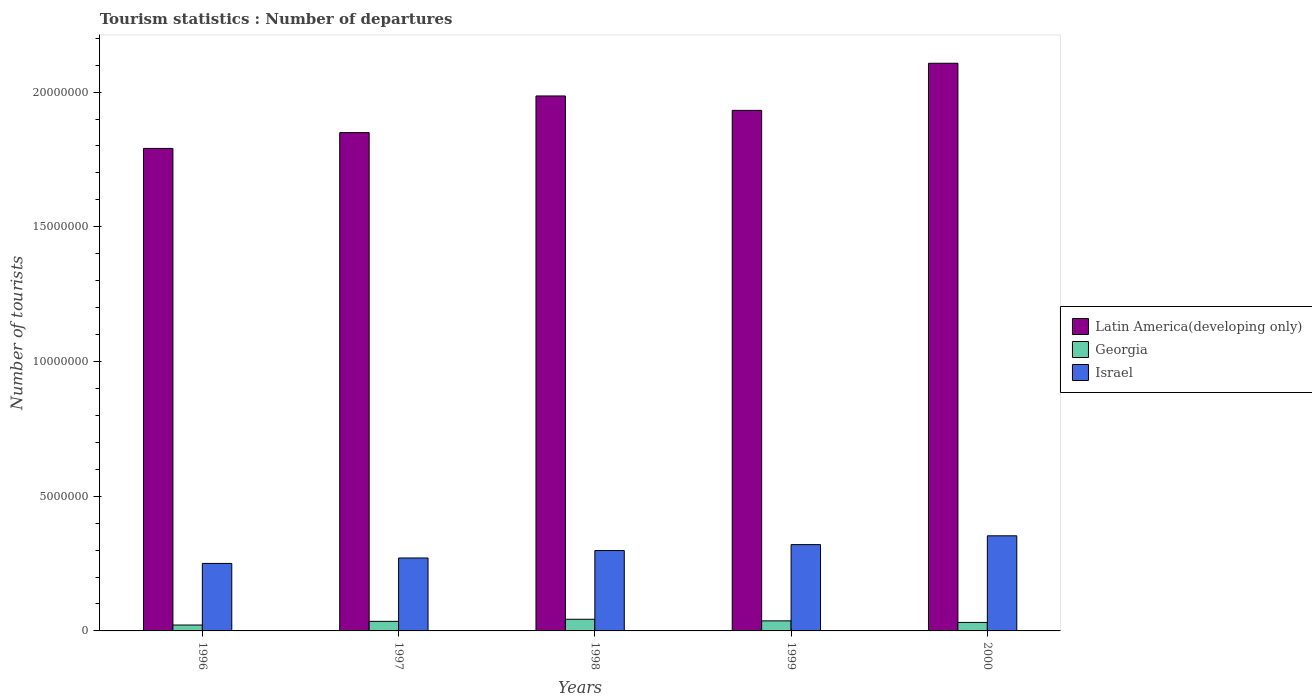How many groups of bars are there?
Keep it short and to the point. 5. Are the number of bars per tick equal to the number of legend labels?
Your response must be concise. Yes. How many bars are there on the 1st tick from the left?
Make the answer very short. 3. How many bars are there on the 4th tick from the right?
Keep it short and to the point. 3. What is the label of the 1st group of bars from the left?
Make the answer very short. 1996. What is the number of tourist departures in Latin America(developing only) in 1999?
Make the answer very short. 1.93e+07. Across all years, what is the maximum number of tourist departures in Georgia?
Your response must be concise. 4.33e+05. Across all years, what is the minimum number of tourist departures in Israel?
Your response must be concise. 2.50e+06. In which year was the number of tourist departures in Latin America(developing only) maximum?
Your response must be concise. 2000. In which year was the number of tourist departures in Georgia minimum?
Your response must be concise. 1996. What is the total number of tourist departures in Israel in the graph?
Your answer should be compact. 1.49e+07. What is the difference between the number of tourist departures in Israel in 1996 and that in 2000?
Offer a terse response. -1.02e+06. What is the difference between the number of tourist departures in Latin America(developing only) in 1998 and the number of tourist departures in Israel in 1999?
Make the answer very short. 1.67e+07. What is the average number of tourist departures in Georgia per year?
Ensure brevity in your answer.  3.39e+05. In the year 1996, what is the difference between the number of tourist departures in Israel and number of tourist departures in Latin America(developing only)?
Ensure brevity in your answer.  -1.54e+07. In how many years, is the number of tourist departures in Latin America(developing only) greater than 11000000?
Make the answer very short. 5. What is the ratio of the number of tourist departures in Israel in 1997 to that in 1998?
Provide a succinct answer. 0.91. What is the difference between the highest and the lowest number of tourist departures in Georgia?
Your response must be concise. 2.14e+05. In how many years, is the number of tourist departures in Georgia greater than the average number of tourist departures in Georgia taken over all years?
Your response must be concise. 3. Is the sum of the number of tourist departures in Israel in 1996 and 2000 greater than the maximum number of tourist departures in Latin America(developing only) across all years?
Make the answer very short. No. What does the 3rd bar from the left in 1996 represents?
Provide a short and direct response. Israel. What does the 1st bar from the right in 1996 represents?
Offer a terse response. Israel. Is it the case that in every year, the sum of the number of tourist departures in Latin America(developing only) and number of tourist departures in Israel is greater than the number of tourist departures in Georgia?
Keep it short and to the point. Yes. How many years are there in the graph?
Offer a terse response. 5. What is the difference between two consecutive major ticks on the Y-axis?
Provide a succinct answer. 5.00e+06. How many legend labels are there?
Keep it short and to the point. 3. How are the legend labels stacked?
Keep it short and to the point. Vertical. What is the title of the graph?
Your answer should be compact. Tourism statistics : Number of departures. Does "Djibouti" appear as one of the legend labels in the graph?
Offer a terse response. No. What is the label or title of the X-axis?
Make the answer very short. Years. What is the label or title of the Y-axis?
Your response must be concise. Number of tourists. What is the Number of tourists of Latin America(developing only) in 1996?
Your response must be concise. 1.79e+07. What is the Number of tourists in Georgia in 1996?
Your response must be concise. 2.19e+05. What is the Number of tourists of Israel in 1996?
Your answer should be compact. 2.50e+06. What is the Number of tourists of Latin America(developing only) in 1997?
Ensure brevity in your answer.  1.85e+07. What is the Number of tourists of Georgia in 1997?
Give a very brief answer. 3.55e+05. What is the Number of tourists of Israel in 1997?
Provide a succinct answer. 2.71e+06. What is the Number of tourists in Latin America(developing only) in 1998?
Keep it short and to the point. 1.99e+07. What is the Number of tourists of Georgia in 1998?
Your answer should be compact. 4.33e+05. What is the Number of tourists in Israel in 1998?
Ensure brevity in your answer.  2.98e+06. What is the Number of tourists of Latin America(developing only) in 1999?
Your answer should be compact. 1.93e+07. What is the Number of tourists of Georgia in 1999?
Your answer should be very brief. 3.73e+05. What is the Number of tourists in Israel in 1999?
Your answer should be compact. 3.20e+06. What is the Number of tourists of Latin America(developing only) in 2000?
Offer a terse response. 2.11e+07. What is the Number of tourists of Georgia in 2000?
Your response must be concise. 3.15e+05. What is the Number of tourists in Israel in 2000?
Your response must be concise. 3.53e+06. Across all years, what is the maximum Number of tourists in Latin America(developing only)?
Offer a terse response. 2.11e+07. Across all years, what is the maximum Number of tourists of Georgia?
Your answer should be very brief. 4.33e+05. Across all years, what is the maximum Number of tourists in Israel?
Provide a succinct answer. 3.53e+06. Across all years, what is the minimum Number of tourists in Latin America(developing only)?
Your response must be concise. 1.79e+07. Across all years, what is the minimum Number of tourists of Georgia?
Your response must be concise. 2.19e+05. Across all years, what is the minimum Number of tourists in Israel?
Offer a very short reply. 2.50e+06. What is the total Number of tourists in Latin America(developing only) in the graph?
Keep it short and to the point. 9.66e+07. What is the total Number of tourists in Georgia in the graph?
Make the answer very short. 1.70e+06. What is the total Number of tourists of Israel in the graph?
Make the answer very short. 1.49e+07. What is the difference between the Number of tourists of Latin America(developing only) in 1996 and that in 1997?
Your answer should be compact. -5.87e+05. What is the difference between the Number of tourists in Georgia in 1996 and that in 1997?
Your response must be concise. -1.36e+05. What is the difference between the Number of tourists in Israel in 1996 and that in 1997?
Keep it short and to the point. -2.02e+05. What is the difference between the Number of tourists in Latin America(developing only) in 1996 and that in 1998?
Your answer should be very brief. -1.95e+06. What is the difference between the Number of tourists of Georgia in 1996 and that in 1998?
Keep it short and to the point. -2.14e+05. What is the difference between the Number of tourists in Israel in 1996 and that in 1998?
Your answer should be very brief. -4.78e+05. What is the difference between the Number of tourists in Latin America(developing only) in 1996 and that in 1999?
Provide a short and direct response. -1.41e+06. What is the difference between the Number of tourists of Georgia in 1996 and that in 1999?
Give a very brief answer. -1.54e+05. What is the difference between the Number of tourists of Israel in 1996 and that in 1999?
Provide a short and direct response. -6.98e+05. What is the difference between the Number of tourists in Latin America(developing only) in 1996 and that in 2000?
Your response must be concise. -3.16e+06. What is the difference between the Number of tourists of Georgia in 1996 and that in 2000?
Offer a very short reply. -9.60e+04. What is the difference between the Number of tourists in Israel in 1996 and that in 2000?
Your answer should be very brief. -1.02e+06. What is the difference between the Number of tourists in Latin America(developing only) in 1997 and that in 1998?
Ensure brevity in your answer.  -1.36e+06. What is the difference between the Number of tourists of Georgia in 1997 and that in 1998?
Give a very brief answer. -7.80e+04. What is the difference between the Number of tourists in Israel in 1997 and that in 1998?
Provide a short and direct response. -2.76e+05. What is the difference between the Number of tourists in Latin America(developing only) in 1997 and that in 1999?
Your answer should be compact. -8.26e+05. What is the difference between the Number of tourists in Georgia in 1997 and that in 1999?
Ensure brevity in your answer.  -1.80e+04. What is the difference between the Number of tourists of Israel in 1997 and that in 1999?
Offer a very short reply. -4.96e+05. What is the difference between the Number of tourists of Latin America(developing only) in 1997 and that in 2000?
Offer a terse response. -2.57e+06. What is the difference between the Number of tourists of Israel in 1997 and that in 2000?
Your answer should be very brief. -8.23e+05. What is the difference between the Number of tourists of Latin America(developing only) in 1998 and that in 1999?
Your answer should be very brief. 5.35e+05. What is the difference between the Number of tourists of Latin America(developing only) in 1998 and that in 2000?
Your answer should be compact. -1.21e+06. What is the difference between the Number of tourists of Georgia in 1998 and that in 2000?
Provide a short and direct response. 1.18e+05. What is the difference between the Number of tourists of Israel in 1998 and that in 2000?
Offer a very short reply. -5.47e+05. What is the difference between the Number of tourists in Latin America(developing only) in 1999 and that in 2000?
Your answer should be compact. -1.75e+06. What is the difference between the Number of tourists of Georgia in 1999 and that in 2000?
Provide a short and direct response. 5.80e+04. What is the difference between the Number of tourists in Israel in 1999 and that in 2000?
Provide a short and direct response. -3.27e+05. What is the difference between the Number of tourists of Latin America(developing only) in 1996 and the Number of tourists of Georgia in 1997?
Give a very brief answer. 1.76e+07. What is the difference between the Number of tourists in Latin America(developing only) in 1996 and the Number of tourists in Israel in 1997?
Offer a very short reply. 1.52e+07. What is the difference between the Number of tourists in Georgia in 1996 and the Number of tourists in Israel in 1997?
Offer a terse response. -2.49e+06. What is the difference between the Number of tourists of Latin America(developing only) in 1996 and the Number of tourists of Georgia in 1998?
Make the answer very short. 1.75e+07. What is the difference between the Number of tourists of Latin America(developing only) in 1996 and the Number of tourists of Israel in 1998?
Provide a succinct answer. 1.49e+07. What is the difference between the Number of tourists of Georgia in 1996 and the Number of tourists of Israel in 1998?
Your answer should be compact. -2.76e+06. What is the difference between the Number of tourists in Latin America(developing only) in 1996 and the Number of tourists in Georgia in 1999?
Make the answer very short. 1.75e+07. What is the difference between the Number of tourists in Latin America(developing only) in 1996 and the Number of tourists in Israel in 1999?
Your response must be concise. 1.47e+07. What is the difference between the Number of tourists in Georgia in 1996 and the Number of tourists in Israel in 1999?
Your answer should be very brief. -2.98e+06. What is the difference between the Number of tourists in Latin America(developing only) in 1996 and the Number of tourists in Georgia in 2000?
Your answer should be very brief. 1.76e+07. What is the difference between the Number of tourists in Latin America(developing only) in 1996 and the Number of tourists in Israel in 2000?
Provide a short and direct response. 1.44e+07. What is the difference between the Number of tourists of Georgia in 1996 and the Number of tourists of Israel in 2000?
Your response must be concise. -3.31e+06. What is the difference between the Number of tourists in Latin America(developing only) in 1997 and the Number of tourists in Georgia in 1998?
Give a very brief answer. 1.81e+07. What is the difference between the Number of tourists in Latin America(developing only) in 1997 and the Number of tourists in Israel in 1998?
Give a very brief answer. 1.55e+07. What is the difference between the Number of tourists in Georgia in 1997 and the Number of tourists in Israel in 1998?
Provide a short and direct response. -2.63e+06. What is the difference between the Number of tourists of Latin America(developing only) in 1997 and the Number of tourists of Georgia in 1999?
Provide a succinct answer. 1.81e+07. What is the difference between the Number of tourists in Latin America(developing only) in 1997 and the Number of tourists in Israel in 1999?
Provide a succinct answer. 1.53e+07. What is the difference between the Number of tourists in Georgia in 1997 and the Number of tourists in Israel in 1999?
Your response must be concise. -2.85e+06. What is the difference between the Number of tourists of Latin America(developing only) in 1997 and the Number of tourists of Georgia in 2000?
Offer a very short reply. 1.82e+07. What is the difference between the Number of tourists of Latin America(developing only) in 1997 and the Number of tourists of Israel in 2000?
Ensure brevity in your answer.  1.50e+07. What is the difference between the Number of tourists of Georgia in 1997 and the Number of tourists of Israel in 2000?
Provide a short and direct response. -3.18e+06. What is the difference between the Number of tourists of Latin America(developing only) in 1998 and the Number of tourists of Georgia in 1999?
Make the answer very short. 1.95e+07. What is the difference between the Number of tourists in Latin America(developing only) in 1998 and the Number of tourists in Israel in 1999?
Give a very brief answer. 1.67e+07. What is the difference between the Number of tourists in Georgia in 1998 and the Number of tourists in Israel in 1999?
Your response must be concise. -2.77e+06. What is the difference between the Number of tourists in Latin America(developing only) in 1998 and the Number of tourists in Georgia in 2000?
Provide a short and direct response. 1.95e+07. What is the difference between the Number of tourists in Latin America(developing only) in 1998 and the Number of tourists in Israel in 2000?
Keep it short and to the point. 1.63e+07. What is the difference between the Number of tourists in Georgia in 1998 and the Number of tourists in Israel in 2000?
Provide a succinct answer. -3.10e+06. What is the difference between the Number of tourists in Latin America(developing only) in 1999 and the Number of tourists in Georgia in 2000?
Your answer should be very brief. 1.90e+07. What is the difference between the Number of tourists of Latin America(developing only) in 1999 and the Number of tourists of Israel in 2000?
Keep it short and to the point. 1.58e+07. What is the difference between the Number of tourists of Georgia in 1999 and the Number of tourists of Israel in 2000?
Your answer should be compact. -3.16e+06. What is the average Number of tourists in Latin America(developing only) per year?
Offer a terse response. 1.93e+07. What is the average Number of tourists in Georgia per year?
Give a very brief answer. 3.39e+05. What is the average Number of tourists in Israel per year?
Provide a succinct answer. 2.99e+06. In the year 1996, what is the difference between the Number of tourists in Latin America(developing only) and Number of tourists in Georgia?
Ensure brevity in your answer.  1.77e+07. In the year 1996, what is the difference between the Number of tourists of Latin America(developing only) and Number of tourists of Israel?
Keep it short and to the point. 1.54e+07. In the year 1996, what is the difference between the Number of tourists in Georgia and Number of tourists in Israel?
Offer a terse response. -2.29e+06. In the year 1997, what is the difference between the Number of tourists in Latin America(developing only) and Number of tourists in Georgia?
Ensure brevity in your answer.  1.81e+07. In the year 1997, what is the difference between the Number of tourists of Latin America(developing only) and Number of tourists of Israel?
Your answer should be very brief. 1.58e+07. In the year 1997, what is the difference between the Number of tourists of Georgia and Number of tourists of Israel?
Your answer should be compact. -2.35e+06. In the year 1998, what is the difference between the Number of tourists of Latin America(developing only) and Number of tourists of Georgia?
Provide a succinct answer. 1.94e+07. In the year 1998, what is the difference between the Number of tourists of Latin America(developing only) and Number of tourists of Israel?
Offer a very short reply. 1.69e+07. In the year 1998, what is the difference between the Number of tourists in Georgia and Number of tourists in Israel?
Your response must be concise. -2.55e+06. In the year 1999, what is the difference between the Number of tourists in Latin America(developing only) and Number of tourists in Georgia?
Offer a terse response. 1.89e+07. In the year 1999, what is the difference between the Number of tourists in Latin America(developing only) and Number of tourists in Israel?
Provide a short and direct response. 1.61e+07. In the year 1999, what is the difference between the Number of tourists in Georgia and Number of tourists in Israel?
Make the answer very short. -2.83e+06. In the year 2000, what is the difference between the Number of tourists in Latin America(developing only) and Number of tourists in Georgia?
Keep it short and to the point. 2.08e+07. In the year 2000, what is the difference between the Number of tourists of Latin America(developing only) and Number of tourists of Israel?
Your response must be concise. 1.75e+07. In the year 2000, what is the difference between the Number of tourists in Georgia and Number of tourists in Israel?
Offer a terse response. -3.22e+06. What is the ratio of the Number of tourists in Latin America(developing only) in 1996 to that in 1997?
Provide a short and direct response. 0.97. What is the ratio of the Number of tourists in Georgia in 1996 to that in 1997?
Keep it short and to the point. 0.62. What is the ratio of the Number of tourists in Israel in 1996 to that in 1997?
Your answer should be compact. 0.93. What is the ratio of the Number of tourists of Latin America(developing only) in 1996 to that in 1998?
Your response must be concise. 0.9. What is the ratio of the Number of tourists of Georgia in 1996 to that in 1998?
Your response must be concise. 0.51. What is the ratio of the Number of tourists of Israel in 1996 to that in 1998?
Keep it short and to the point. 0.84. What is the ratio of the Number of tourists of Latin America(developing only) in 1996 to that in 1999?
Provide a succinct answer. 0.93. What is the ratio of the Number of tourists in Georgia in 1996 to that in 1999?
Your response must be concise. 0.59. What is the ratio of the Number of tourists of Israel in 1996 to that in 1999?
Your answer should be very brief. 0.78. What is the ratio of the Number of tourists in Georgia in 1996 to that in 2000?
Ensure brevity in your answer.  0.7. What is the ratio of the Number of tourists in Israel in 1996 to that in 2000?
Make the answer very short. 0.71. What is the ratio of the Number of tourists of Latin America(developing only) in 1997 to that in 1998?
Your response must be concise. 0.93. What is the ratio of the Number of tourists in Georgia in 1997 to that in 1998?
Your answer should be compact. 0.82. What is the ratio of the Number of tourists of Israel in 1997 to that in 1998?
Your response must be concise. 0.91. What is the ratio of the Number of tourists in Latin America(developing only) in 1997 to that in 1999?
Ensure brevity in your answer.  0.96. What is the ratio of the Number of tourists of Georgia in 1997 to that in 1999?
Make the answer very short. 0.95. What is the ratio of the Number of tourists in Israel in 1997 to that in 1999?
Ensure brevity in your answer.  0.85. What is the ratio of the Number of tourists in Latin America(developing only) in 1997 to that in 2000?
Make the answer very short. 0.88. What is the ratio of the Number of tourists of Georgia in 1997 to that in 2000?
Provide a succinct answer. 1.13. What is the ratio of the Number of tourists of Israel in 1997 to that in 2000?
Ensure brevity in your answer.  0.77. What is the ratio of the Number of tourists of Latin America(developing only) in 1998 to that in 1999?
Provide a short and direct response. 1.03. What is the ratio of the Number of tourists in Georgia in 1998 to that in 1999?
Make the answer very short. 1.16. What is the ratio of the Number of tourists of Israel in 1998 to that in 1999?
Your answer should be compact. 0.93. What is the ratio of the Number of tourists of Latin America(developing only) in 1998 to that in 2000?
Provide a succinct answer. 0.94. What is the ratio of the Number of tourists in Georgia in 1998 to that in 2000?
Give a very brief answer. 1.37. What is the ratio of the Number of tourists of Israel in 1998 to that in 2000?
Keep it short and to the point. 0.84. What is the ratio of the Number of tourists of Latin America(developing only) in 1999 to that in 2000?
Your answer should be very brief. 0.92. What is the ratio of the Number of tourists of Georgia in 1999 to that in 2000?
Ensure brevity in your answer.  1.18. What is the ratio of the Number of tourists of Israel in 1999 to that in 2000?
Your answer should be compact. 0.91. What is the difference between the highest and the second highest Number of tourists in Latin America(developing only)?
Your answer should be compact. 1.21e+06. What is the difference between the highest and the second highest Number of tourists of Georgia?
Ensure brevity in your answer.  6.00e+04. What is the difference between the highest and the second highest Number of tourists in Israel?
Provide a short and direct response. 3.27e+05. What is the difference between the highest and the lowest Number of tourists in Latin America(developing only)?
Provide a short and direct response. 3.16e+06. What is the difference between the highest and the lowest Number of tourists in Georgia?
Provide a short and direct response. 2.14e+05. What is the difference between the highest and the lowest Number of tourists in Israel?
Make the answer very short. 1.02e+06. 